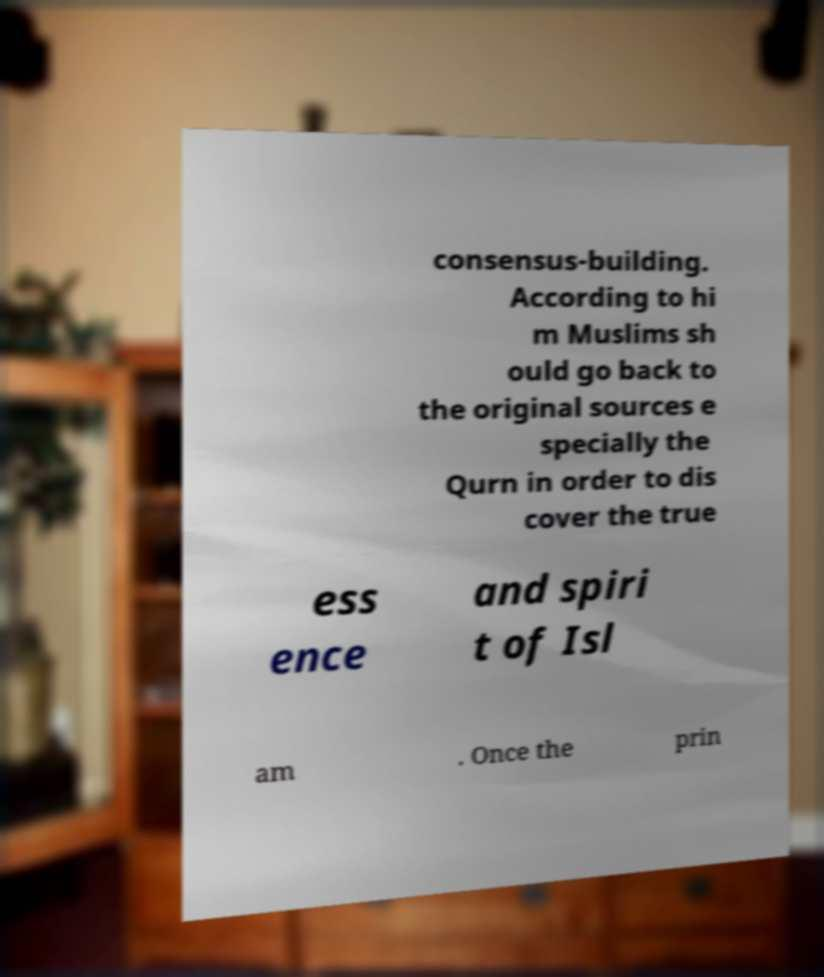Could you assist in decoding the text presented in this image and type it out clearly? consensus-building. According to hi m Muslims sh ould go back to the original sources e specially the Qurn in order to dis cover the true ess ence and spiri t of Isl am . Once the prin 